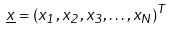Convert formula to latex. <formula><loc_0><loc_0><loc_500><loc_500>\underline { x } = ( x _ { 1 } , x _ { 2 } , x _ { 3 } , \dots , x _ { N } ) ^ { T }</formula> 